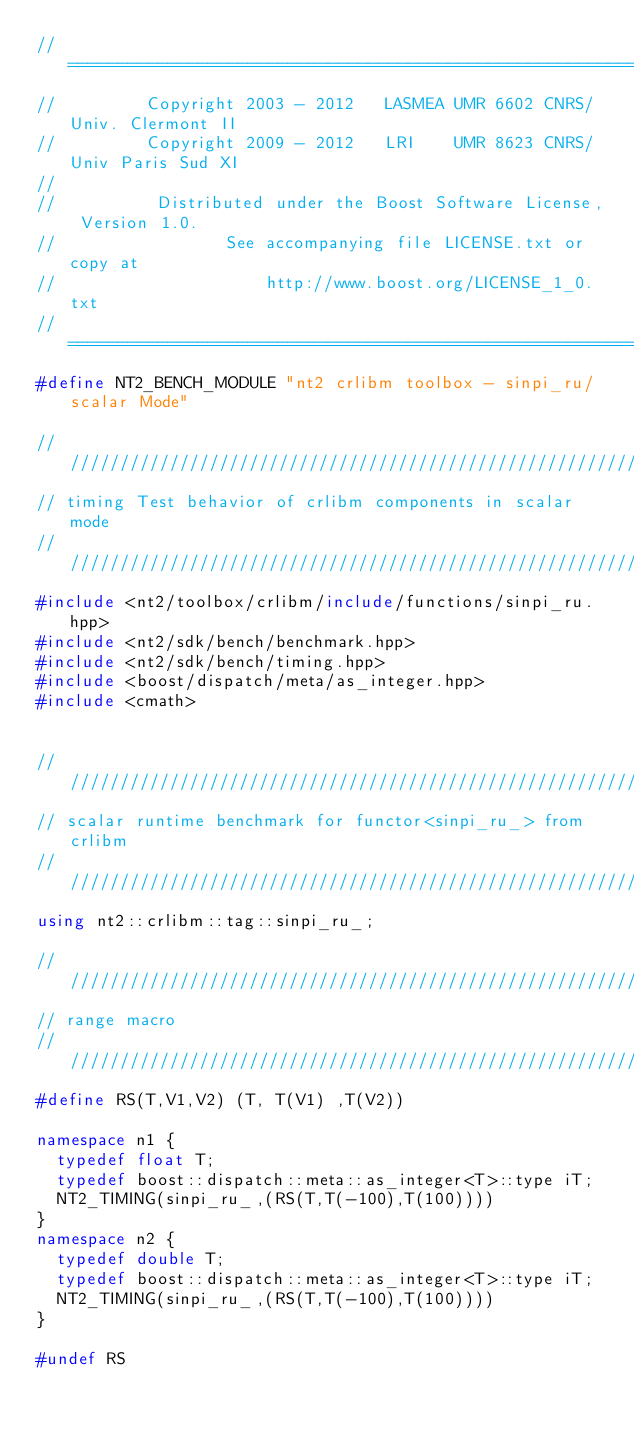Convert code to text. <code><loc_0><loc_0><loc_500><loc_500><_C++_>//==============================================================================
//         Copyright 2003 - 2012   LASMEA UMR 6602 CNRS/Univ. Clermont II
//         Copyright 2009 - 2012   LRI    UMR 8623 CNRS/Univ Paris Sud XI
//
//          Distributed under the Boost Software License, Version 1.0.
//                 See accompanying file LICENSE.txt or copy at
//                     http://www.boost.org/LICENSE_1_0.txt
//==============================================================================
#define NT2_BENCH_MODULE "nt2 crlibm toolbox - sinpi_ru/scalar Mode"

//////////////////////////////////////////////////////////////////////////////
// timing Test behavior of crlibm components in scalar mode
//////////////////////////////////////////////////////////////////////////////
#include <nt2/toolbox/crlibm/include/functions/sinpi_ru.hpp>
#include <nt2/sdk/bench/benchmark.hpp>
#include <nt2/sdk/bench/timing.hpp>
#include <boost/dispatch/meta/as_integer.hpp>
#include <cmath>


//////////////////////////////////////////////////////////////////////////////
// scalar runtime benchmark for functor<sinpi_ru_> from crlibm
//////////////////////////////////////////////////////////////////////////////
using nt2::crlibm::tag::sinpi_ru_;

//////////////////////////////////////////////////////////////////////////////
// range macro
//////////////////////////////////////////////////////////////////////////////
#define RS(T,V1,V2) (T, T(V1) ,T(V2))

namespace n1 {
  typedef float T;
  typedef boost::dispatch::meta::as_integer<T>::type iT;
  NT2_TIMING(sinpi_ru_,(RS(T,T(-100),T(100))))
}
namespace n2 {
  typedef double T;
  typedef boost::dispatch::meta::as_integer<T>::type iT;
  NT2_TIMING(sinpi_ru_,(RS(T,T(-100),T(100))))
}

#undef RS
</code> 